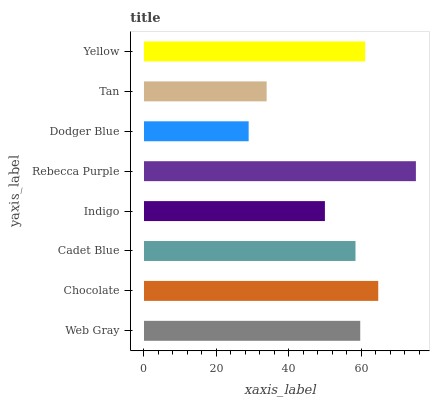Is Dodger Blue the minimum?
Answer yes or no. Yes. Is Rebecca Purple the maximum?
Answer yes or no. Yes. Is Chocolate the minimum?
Answer yes or no. No. Is Chocolate the maximum?
Answer yes or no. No. Is Chocolate greater than Web Gray?
Answer yes or no. Yes. Is Web Gray less than Chocolate?
Answer yes or no. Yes. Is Web Gray greater than Chocolate?
Answer yes or no. No. Is Chocolate less than Web Gray?
Answer yes or no. No. Is Web Gray the high median?
Answer yes or no. Yes. Is Cadet Blue the low median?
Answer yes or no. Yes. Is Rebecca Purple the high median?
Answer yes or no. No. Is Web Gray the low median?
Answer yes or no. No. 